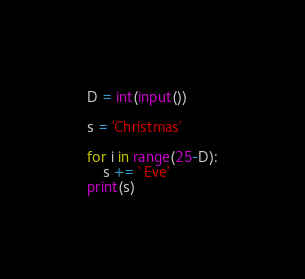Convert code to text. <code><loc_0><loc_0><loc_500><loc_500><_Python_>D = int(input())

s = 'Christmas'

for i in range(25-D):
    s += ' Eve'
print(s)
</code> 